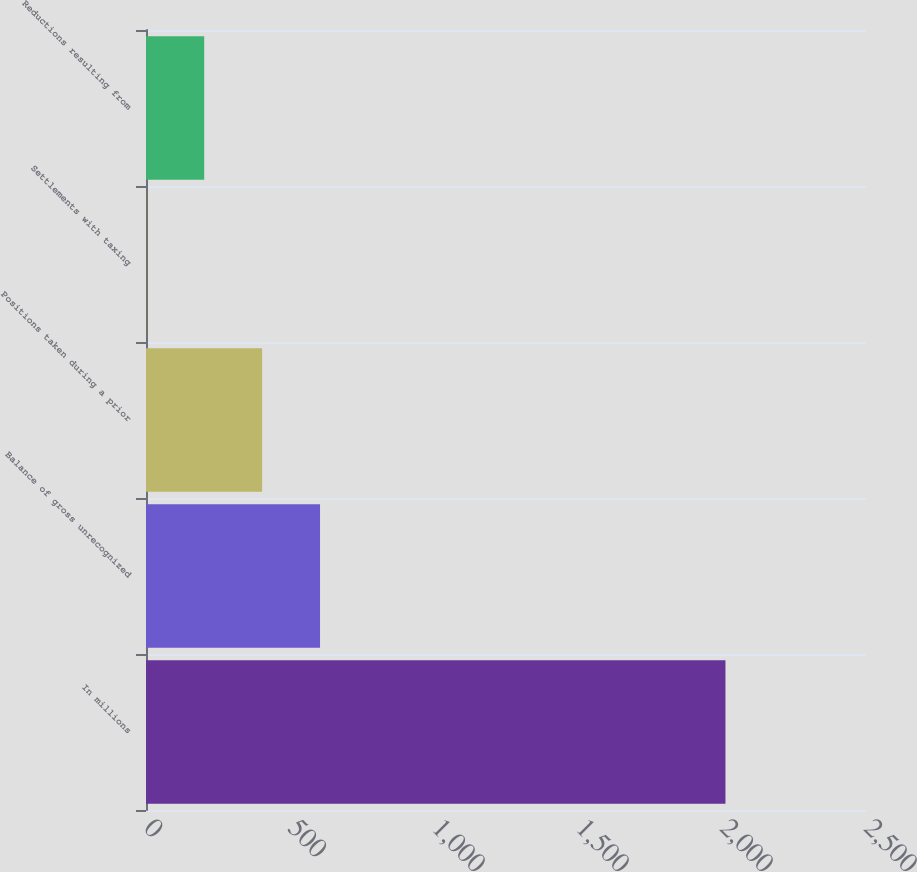Convert chart. <chart><loc_0><loc_0><loc_500><loc_500><bar_chart><fcel>In millions<fcel>Balance of gross unrecognized<fcel>Positions taken during a prior<fcel>Settlements with taxing<fcel>Reductions resulting from<nl><fcel>2012<fcel>604.3<fcel>403.2<fcel>1<fcel>202.1<nl></chart> 